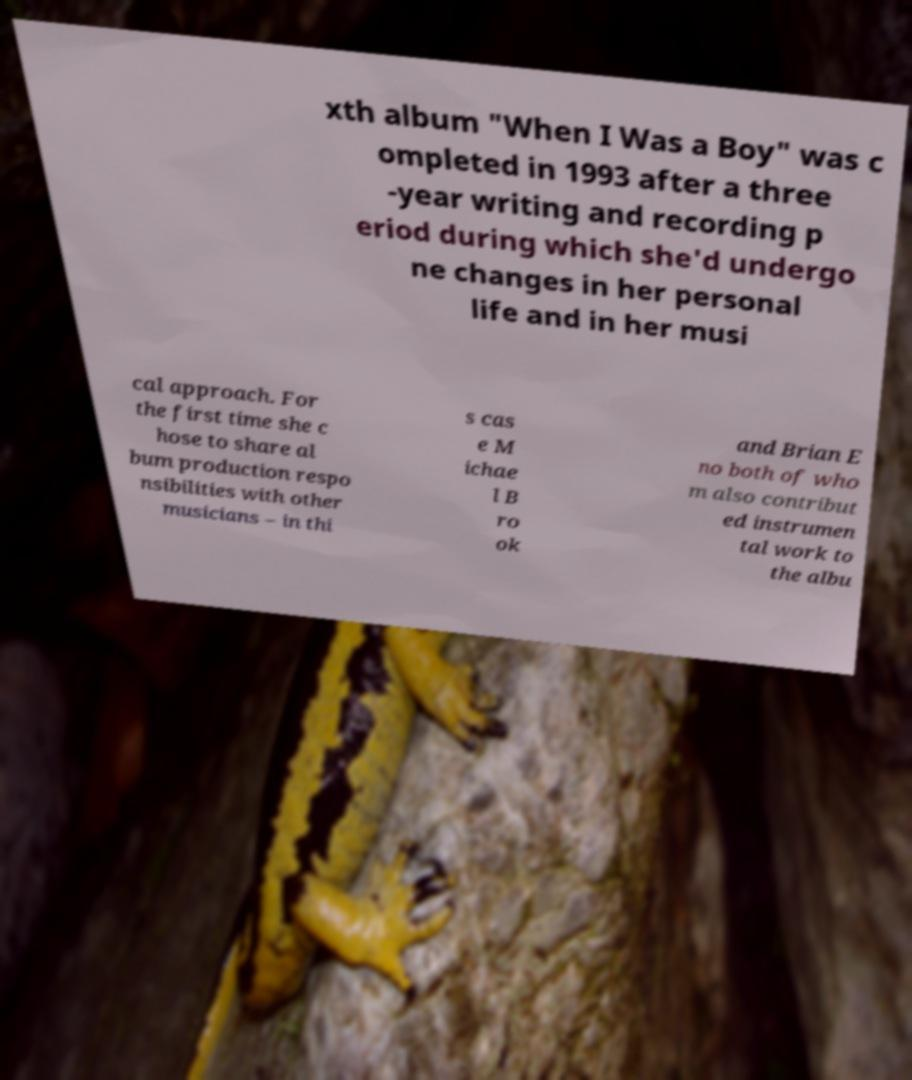Can you read and provide the text displayed in the image?This photo seems to have some interesting text. Can you extract and type it out for me? xth album "When I Was a Boy" was c ompleted in 1993 after a three -year writing and recording p eriod during which she'd undergo ne changes in her personal life and in her musi cal approach. For the first time she c hose to share al bum production respo nsibilities with other musicians – in thi s cas e M ichae l B ro ok and Brian E no both of who m also contribut ed instrumen tal work to the albu 